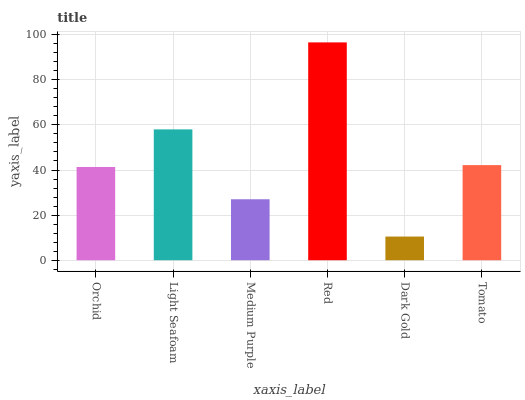Is Dark Gold the minimum?
Answer yes or no. Yes. Is Red the maximum?
Answer yes or no. Yes. Is Light Seafoam the minimum?
Answer yes or no. No. Is Light Seafoam the maximum?
Answer yes or no. No. Is Light Seafoam greater than Orchid?
Answer yes or no. Yes. Is Orchid less than Light Seafoam?
Answer yes or no. Yes. Is Orchid greater than Light Seafoam?
Answer yes or no. No. Is Light Seafoam less than Orchid?
Answer yes or no. No. Is Tomato the high median?
Answer yes or no. Yes. Is Orchid the low median?
Answer yes or no. Yes. Is Light Seafoam the high median?
Answer yes or no. No. Is Tomato the low median?
Answer yes or no. No. 